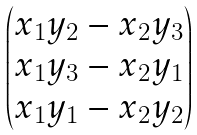<formula> <loc_0><loc_0><loc_500><loc_500>\begin{pmatrix} x _ { 1 } y _ { 2 } - x _ { 2 } y _ { 3 } \\ x _ { 1 } y _ { 3 } - x _ { 2 } y _ { 1 } \\ x _ { 1 } y _ { 1 } - x _ { 2 } y _ { 2 } \end{pmatrix}</formula> 